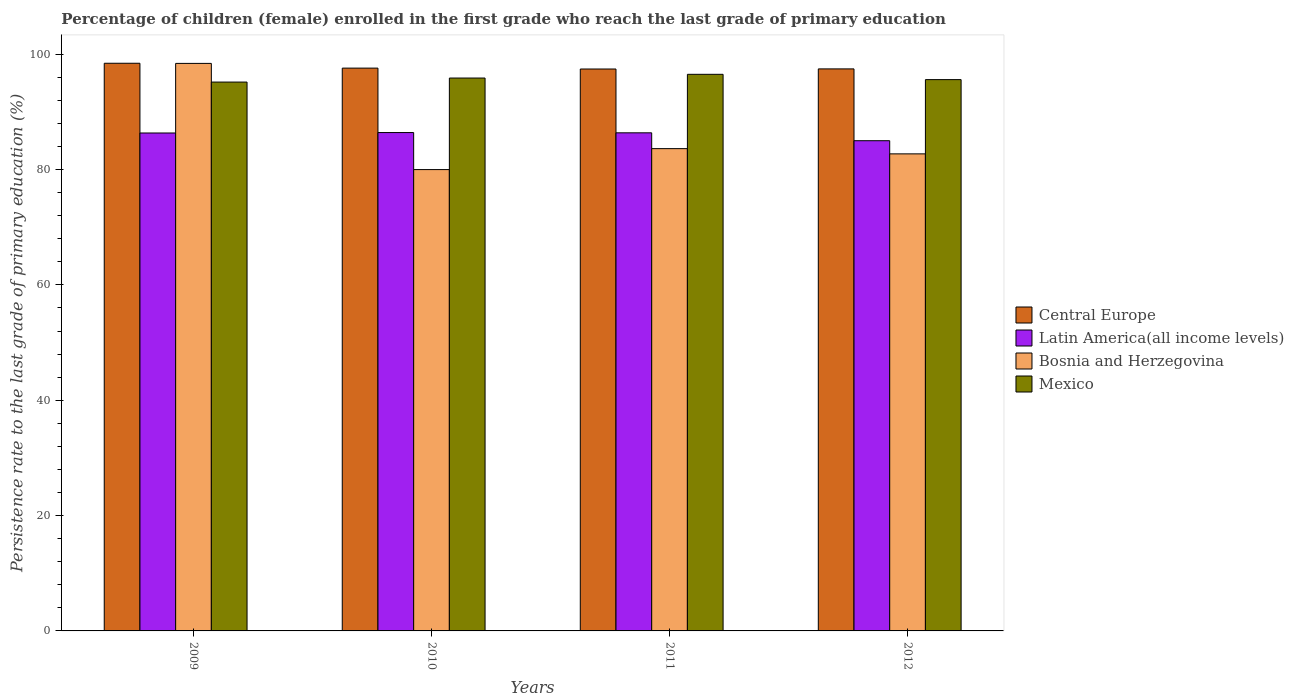How many different coloured bars are there?
Make the answer very short. 4. How many groups of bars are there?
Ensure brevity in your answer.  4. Are the number of bars on each tick of the X-axis equal?
Make the answer very short. Yes. How many bars are there on the 1st tick from the right?
Keep it short and to the point. 4. What is the persistence rate of children in Bosnia and Herzegovina in 2011?
Make the answer very short. 83.63. Across all years, what is the maximum persistence rate of children in Bosnia and Herzegovina?
Your answer should be very brief. 98.41. Across all years, what is the minimum persistence rate of children in Bosnia and Herzegovina?
Ensure brevity in your answer.  80. In which year was the persistence rate of children in Latin America(all income levels) maximum?
Offer a terse response. 2010. In which year was the persistence rate of children in Central Europe minimum?
Make the answer very short. 2011. What is the total persistence rate of children in Mexico in the graph?
Make the answer very short. 383.18. What is the difference between the persistence rate of children in Central Europe in 2009 and that in 2011?
Your answer should be compact. 1. What is the difference between the persistence rate of children in Bosnia and Herzegovina in 2011 and the persistence rate of children in Mexico in 2010?
Your answer should be very brief. -12.24. What is the average persistence rate of children in Bosnia and Herzegovina per year?
Provide a succinct answer. 86.19. In the year 2011, what is the difference between the persistence rate of children in Mexico and persistence rate of children in Central Europe?
Your response must be concise. -0.92. In how many years, is the persistence rate of children in Central Europe greater than 72 %?
Your answer should be compact. 4. What is the ratio of the persistence rate of children in Latin America(all income levels) in 2010 to that in 2012?
Provide a short and direct response. 1.02. Is the persistence rate of children in Bosnia and Herzegovina in 2009 less than that in 2010?
Your response must be concise. No. Is the difference between the persistence rate of children in Mexico in 2010 and 2011 greater than the difference between the persistence rate of children in Central Europe in 2010 and 2011?
Ensure brevity in your answer.  No. What is the difference between the highest and the second highest persistence rate of children in Latin America(all income levels)?
Make the answer very short. 0.05. What is the difference between the highest and the lowest persistence rate of children in Bosnia and Herzegovina?
Ensure brevity in your answer.  18.41. Is it the case that in every year, the sum of the persistence rate of children in Mexico and persistence rate of children in Bosnia and Herzegovina is greater than the sum of persistence rate of children in Central Europe and persistence rate of children in Latin America(all income levels)?
Give a very brief answer. No. What does the 3rd bar from the right in 2012 represents?
Your response must be concise. Latin America(all income levels). Does the graph contain any zero values?
Make the answer very short. No. What is the title of the graph?
Give a very brief answer. Percentage of children (female) enrolled in the first grade who reach the last grade of primary education. Does "New Zealand" appear as one of the legend labels in the graph?
Offer a very short reply. No. What is the label or title of the X-axis?
Your response must be concise. Years. What is the label or title of the Y-axis?
Your response must be concise. Persistence rate to the last grade of primary education (%). What is the Persistence rate to the last grade of primary education (%) in Central Europe in 2009?
Keep it short and to the point. 98.44. What is the Persistence rate to the last grade of primary education (%) in Latin America(all income levels) in 2009?
Offer a terse response. 86.35. What is the Persistence rate to the last grade of primary education (%) of Bosnia and Herzegovina in 2009?
Offer a very short reply. 98.41. What is the Persistence rate to the last grade of primary education (%) in Mexico in 2009?
Provide a succinct answer. 95.18. What is the Persistence rate to the last grade of primary education (%) in Central Europe in 2010?
Offer a very short reply. 97.6. What is the Persistence rate to the last grade of primary education (%) of Latin America(all income levels) in 2010?
Offer a very short reply. 86.42. What is the Persistence rate to the last grade of primary education (%) of Bosnia and Herzegovina in 2010?
Offer a terse response. 80. What is the Persistence rate to the last grade of primary education (%) in Mexico in 2010?
Your answer should be compact. 95.88. What is the Persistence rate to the last grade of primary education (%) in Central Europe in 2011?
Give a very brief answer. 97.44. What is the Persistence rate to the last grade of primary education (%) in Latin America(all income levels) in 2011?
Ensure brevity in your answer.  86.38. What is the Persistence rate to the last grade of primary education (%) in Bosnia and Herzegovina in 2011?
Keep it short and to the point. 83.63. What is the Persistence rate to the last grade of primary education (%) in Mexico in 2011?
Offer a very short reply. 96.52. What is the Persistence rate to the last grade of primary education (%) of Central Europe in 2012?
Make the answer very short. 97.46. What is the Persistence rate to the last grade of primary education (%) of Latin America(all income levels) in 2012?
Make the answer very short. 85.01. What is the Persistence rate to the last grade of primary education (%) in Bosnia and Herzegovina in 2012?
Ensure brevity in your answer.  82.73. What is the Persistence rate to the last grade of primary education (%) of Mexico in 2012?
Your answer should be very brief. 95.6. Across all years, what is the maximum Persistence rate to the last grade of primary education (%) in Central Europe?
Ensure brevity in your answer.  98.44. Across all years, what is the maximum Persistence rate to the last grade of primary education (%) of Latin America(all income levels)?
Your answer should be very brief. 86.42. Across all years, what is the maximum Persistence rate to the last grade of primary education (%) in Bosnia and Herzegovina?
Give a very brief answer. 98.41. Across all years, what is the maximum Persistence rate to the last grade of primary education (%) in Mexico?
Provide a short and direct response. 96.52. Across all years, what is the minimum Persistence rate to the last grade of primary education (%) of Central Europe?
Your answer should be very brief. 97.44. Across all years, what is the minimum Persistence rate to the last grade of primary education (%) in Latin America(all income levels)?
Keep it short and to the point. 85.01. Across all years, what is the minimum Persistence rate to the last grade of primary education (%) in Bosnia and Herzegovina?
Offer a very short reply. 80. Across all years, what is the minimum Persistence rate to the last grade of primary education (%) in Mexico?
Make the answer very short. 95.18. What is the total Persistence rate to the last grade of primary education (%) in Central Europe in the graph?
Keep it short and to the point. 390.94. What is the total Persistence rate to the last grade of primary education (%) of Latin America(all income levels) in the graph?
Your answer should be very brief. 344.15. What is the total Persistence rate to the last grade of primary education (%) in Bosnia and Herzegovina in the graph?
Make the answer very short. 344.78. What is the total Persistence rate to the last grade of primary education (%) of Mexico in the graph?
Provide a succinct answer. 383.18. What is the difference between the Persistence rate to the last grade of primary education (%) of Central Europe in 2009 and that in 2010?
Ensure brevity in your answer.  0.84. What is the difference between the Persistence rate to the last grade of primary education (%) in Latin America(all income levels) in 2009 and that in 2010?
Keep it short and to the point. -0.08. What is the difference between the Persistence rate to the last grade of primary education (%) in Bosnia and Herzegovina in 2009 and that in 2010?
Provide a short and direct response. 18.41. What is the difference between the Persistence rate to the last grade of primary education (%) in Mexico in 2009 and that in 2010?
Ensure brevity in your answer.  -0.7. What is the difference between the Persistence rate to the last grade of primary education (%) in Latin America(all income levels) in 2009 and that in 2011?
Give a very brief answer. -0.03. What is the difference between the Persistence rate to the last grade of primary education (%) in Bosnia and Herzegovina in 2009 and that in 2011?
Make the answer very short. 14.78. What is the difference between the Persistence rate to the last grade of primary education (%) in Mexico in 2009 and that in 2011?
Provide a succinct answer. -1.35. What is the difference between the Persistence rate to the last grade of primary education (%) in Central Europe in 2009 and that in 2012?
Provide a succinct answer. 0.98. What is the difference between the Persistence rate to the last grade of primary education (%) of Latin America(all income levels) in 2009 and that in 2012?
Your response must be concise. 1.34. What is the difference between the Persistence rate to the last grade of primary education (%) of Bosnia and Herzegovina in 2009 and that in 2012?
Give a very brief answer. 15.69. What is the difference between the Persistence rate to the last grade of primary education (%) in Mexico in 2009 and that in 2012?
Your answer should be compact. -0.43. What is the difference between the Persistence rate to the last grade of primary education (%) of Central Europe in 2010 and that in 2011?
Make the answer very short. 0.15. What is the difference between the Persistence rate to the last grade of primary education (%) in Latin America(all income levels) in 2010 and that in 2011?
Ensure brevity in your answer.  0.05. What is the difference between the Persistence rate to the last grade of primary education (%) in Bosnia and Herzegovina in 2010 and that in 2011?
Offer a terse response. -3.63. What is the difference between the Persistence rate to the last grade of primary education (%) in Mexico in 2010 and that in 2011?
Keep it short and to the point. -0.65. What is the difference between the Persistence rate to the last grade of primary education (%) of Central Europe in 2010 and that in 2012?
Ensure brevity in your answer.  0.13. What is the difference between the Persistence rate to the last grade of primary education (%) in Latin America(all income levels) in 2010 and that in 2012?
Your answer should be compact. 1.41. What is the difference between the Persistence rate to the last grade of primary education (%) of Bosnia and Herzegovina in 2010 and that in 2012?
Your response must be concise. -2.73. What is the difference between the Persistence rate to the last grade of primary education (%) of Mexico in 2010 and that in 2012?
Offer a very short reply. 0.27. What is the difference between the Persistence rate to the last grade of primary education (%) in Central Europe in 2011 and that in 2012?
Offer a very short reply. -0.02. What is the difference between the Persistence rate to the last grade of primary education (%) in Latin America(all income levels) in 2011 and that in 2012?
Provide a succinct answer. 1.37. What is the difference between the Persistence rate to the last grade of primary education (%) of Bosnia and Herzegovina in 2011 and that in 2012?
Offer a terse response. 0.91. What is the difference between the Persistence rate to the last grade of primary education (%) of Mexico in 2011 and that in 2012?
Your answer should be compact. 0.92. What is the difference between the Persistence rate to the last grade of primary education (%) in Central Europe in 2009 and the Persistence rate to the last grade of primary education (%) in Latin America(all income levels) in 2010?
Provide a short and direct response. 12.02. What is the difference between the Persistence rate to the last grade of primary education (%) in Central Europe in 2009 and the Persistence rate to the last grade of primary education (%) in Bosnia and Herzegovina in 2010?
Provide a succinct answer. 18.44. What is the difference between the Persistence rate to the last grade of primary education (%) of Central Europe in 2009 and the Persistence rate to the last grade of primary education (%) of Mexico in 2010?
Offer a terse response. 2.56. What is the difference between the Persistence rate to the last grade of primary education (%) in Latin America(all income levels) in 2009 and the Persistence rate to the last grade of primary education (%) in Bosnia and Herzegovina in 2010?
Offer a terse response. 6.35. What is the difference between the Persistence rate to the last grade of primary education (%) in Latin America(all income levels) in 2009 and the Persistence rate to the last grade of primary education (%) in Mexico in 2010?
Offer a terse response. -9.53. What is the difference between the Persistence rate to the last grade of primary education (%) in Bosnia and Herzegovina in 2009 and the Persistence rate to the last grade of primary education (%) in Mexico in 2010?
Make the answer very short. 2.54. What is the difference between the Persistence rate to the last grade of primary education (%) of Central Europe in 2009 and the Persistence rate to the last grade of primary education (%) of Latin America(all income levels) in 2011?
Your answer should be compact. 12.06. What is the difference between the Persistence rate to the last grade of primary education (%) in Central Europe in 2009 and the Persistence rate to the last grade of primary education (%) in Bosnia and Herzegovina in 2011?
Your answer should be very brief. 14.81. What is the difference between the Persistence rate to the last grade of primary education (%) of Central Europe in 2009 and the Persistence rate to the last grade of primary education (%) of Mexico in 2011?
Provide a short and direct response. 1.92. What is the difference between the Persistence rate to the last grade of primary education (%) of Latin America(all income levels) in 2009 and the Persistence rate to the last grade of primary education (%) of Bosnia and Herzegovina in 2011?
Your answer should be compact. 2.71. What is the difference between the Persistence rate to the last grade of primary education (%) of Latin America(all income levels) in 2009 and the Persistence rate to the last grade of primary education (%) of Mexico in 2011?
Make the answer very short. -10.18. What is the difference between the Persistence rate to the last grade of primary education (%) in Bosnia and Herzegovina in 2009 and the Persistence rate to the last grade of primary education (%) in Mexico in 2011?
Provide a succinct answer. 1.89. What is the difference between the Persistence rate to the last grade of primary education (%) in Central Europe in 2009 and the Persistence rate to the last grade of primary education (%) in Latin America(all income levels) in 2012?
Your response must be concise. 13.43. What is the difference between the Persistence rate to the last grade of primary education (%) in Central Europe in 2009 and the Persistence rate to the last grade of primary education (%) in Bosnia and Herzegovina in 2012?
Offer a very short reply. 15.71. What is the difference between the Persistence rate to the last grade of primary education (%) in Central Europe in 2009 and the Persistence rate to the last grade of primary education (%) in Mexico in 2012?
Keep it short and to the point. 2.84. What is the difference between the Persistence rate to the last grade of primary education (%) of Latin America(all income levels) in 2009 and the Persistence rate to the last grade of primary education (%) of Bosnia and Herzegovina in 2012?
Ensure brevity in your answer.  3.62. What is the difference between the Persistence rate to the last grade of primary education (%) of Latin America(all income levels) in 2009 and the Persistence rate to the last grade of primary education (%) of Mexico in 2012?
Give a very brief answer. -9.26. What is the difference between the Persistence rate to the last grade of primary education (%) in Bosnia and Herzegovina in 2009 and the Persistence rate to the last grade of primary education (%) in Mexico in 2012?
Ensure brevity in your answer.  2.81. What is the difference between the Persistence rate to the last grade of primary education (%) of Central Europe in 2010 and the Persistence rate to the last grade of primary education (%) of Latin America(all income levels) in 2011?
Your answer should be compact. 11.22. What is the difference between the Persistence rate to the last grade of primary education (%) of Central Europe in 2010 and the Persistence rate to the last grade of primary education (%) of Bosnia and Herzegovina in 2011?
Offer a very short reply. 13.96. What is the difference between the Persistence rate to the last grade of primary education (%) of Central Europe in 2010 and the Persistence rate to the last grade of primary education (%) of Mexico in 2011?
Ensure brevity in your answer.  1.07. What is the difference between the Persistence rate to the last grade of primary education (%) in Latin America(all income levels) in 2010 and the Persistence rate to the last grade of primary education (%) in Bosnia and Herzegovina in 2011?
Your answer should be compact. 2.79. What is the difference between the Persistence rate to the last grade of primary education (%) of Latin America(all income levels) in 2010 and the Persistence rate to the last grade of primary education (%) of Mexico in 2011?
Your answer should be compact. -10.1. What is the difference between the Persistence rate to the last grade of primary education (%) in Bosnia and Herzegovina in 2010 and the Persistence rate to the last grade of primary education (%) in Mexico in 2011?
Make the answer very short. -16.52. What is the difference between the Persistence rate to the last grade of primary education (%) in Central Europe in 2010 and the Persistence rate to the last grade of primary education (%) in Latin America(all income levels) in 2012?
Offer a terse response. 12.59. What is the difference between the Persistence rate to the last grade of primary education (%) in Central Europe in 2010 and the Persistence rate to the last grade of primary education (%) in Bosnia and Herzegovina in 2012?
Offer a very short reply. 14.87. What is the difference between the Persistence rate to the last grade of primary education (%) of Central Europe in 2010 and the Persistence rate to the last grade of primary education (%) of Mexico in 2012?
Your answer should be very brief. 1.99. What is the difference between the Persistence rate to the last grade of primary education (%) of Latin America(all income levels) in 2010 and the Persistence rate to the last grade of primary education (%) of Bosnia and Herzegovina in 2012?
Provide a succinct answer. 3.7. What is the difference between the Persistence rate to the last grade of primary education (%) of Latin America(all income levels) in 2010 and the Persistence rate to the last grade of primary education (%) of Mexico in 2012?
Provide a short and direct response. -9.18. What is the difference between the Persistence rate to the last grade of primary education (%) in Bosnia and Herzegovina in 2010 and the Persistence rate to the last grade of primary education (%) in Mexico in 2012?
Provide a short and direct response. -15.6. What is the difference between the Persistence rate to the last grade of primary education (%) in Central Europe in 2011 and the Persistence rate to the last grade of primary education (%) in Latin America(all income levels) in 2012?
Provide a succinct answer. 12.43. What is the difference between the Persistence rate to the last grade of primary education (%) in Central Europe in 2011 and the Persistence rate to the last grade of primary education (%) in Bosnia and Herzegovina in 2012?
Give a very brief answer. 14.72. What is the difference between the Persistence rate to the last grade of primary education (%) in Central Europe in 2011 and the Persistence rate to the last grade of primary education (%) in Mexico in 2012?
Provide a succinct answer. 1.84. What is the difference between the Persistence rate to the last grade of primary education (%) in Latin America(all income levels) in 2011 and the Persistence rate to the last grade of primary education (%) in Bosnia and Herzegovina in 2012?
Provide a short and direct response. 3.65. What is the difference between the Persistence rate to the last grade of primary education (%) of Latin America(all income levels) in 2011 and the Persistence rate to the last grade of primary education (%) of Mexico in 2012?
Keep it short and to the point. -9.23. What is the difference between the Persistence rate to the last grade of primary education (%) in Bosnia and Herzegovina in 2011 and the Persistence rate to the last grade of primary education (%) in Mexico in 2012?
Provide a succinct answer. -11.97. What is the average Persistence rate to the last grade of primary education (%) of Central Europe per year?
Your response must be concise. 97.74. What is the average Persistence rate to the last grade of primary education (%) in Latin America(all income levels) per year?
Offer a very short reply. 86.04. What is the average Persistence rate to the last grade of primary education (%) of Bosnia and Herzegovina per year?
Offer a very short reply. 86.19. What is the average Persistence rate to the last grade of primary education (%) in Mexico per year?
Your answer should be compact. 95.79. In the year 2009, what is the difference between the Persistence rate to the last grade of primary education (%) of Central Europe and Persistence rate to the last grade of primary education (%) of Latin America(all income levels)?
Your response must be concise. 12.09. In the year 2009, what is the difference between the Persistence rate to the last grade of primary education (%) in Central Europe and Persistence rate to the last grade of primary education (%) in Bosnia and Herzegovina?
Your response must be concise. 0.02. In the year 2009, what is the difference between the Persistence rate to the last grade of primary education (%) of Central Europe and Persistence rate to the last grade of primary education (%) of Mexico?
Give a very brief answer. 3.26. In the year 2009, what is the difference between the Persistence rate to the last grade of primary education (%) in Latin America(all income levels) and Persistence rate to the last grade of primary education (%) in Bosnia and Herzegovina?
Provide a succinct answer. -12.07. In the year 2009, what is the difference between the Persistence rate to the last grade of primary education (%) of Latin America(all income levels) and Persistence rate to the last grade of primary education (%) of Mexico?
Offer a terse response. -8.83. In the year 2009, what is the difference between the Persistence rate to the last grade of primary education (%) in Bosnia and Herzegovina and Persistence rate to the last grade of primary education (%) in Mexico?
Ensure brevity in your answer.  3.24. In the year 2010, what is the difference between the Persistence rate to the last grade of primary education (%) of Central Europe and Persistence rate to the last grade of primary education (%) of Latin America(all income levels)?
Keep it short and to the point. 11.17. In the year 2010, what is the difference between the Persistence rate to the last grade of primary education (%) in Central Europe and Persistence rate to the last grade of primary education (%) in Bosnia and Herzegovina?
Offer a terse response. 17.6. In the year 2010, what is the difference between the Persistence rate to the last grade of primary education (%) of Central Europe and Persistence rate to the last grade of primary education (%) of Mexico?
Your response must be concise. 1.72. In the year 2010, what is the difference between the Persistence rate to the last grade of primary education (%) of Latin America(all income levels) and Persistence rate to the last grade of primary education (%) of Bosnia and Herzegovina?
Offer a very short reply. 6.42. In the year 2010, what is the difference between the Persistence rate to the last grade of primary education (%) in Latin America(all income levels) and Persistence rate to the last grade of primary education (%) in Mexico?
Provide a short and direct response. -9.45. In the year 2010, what is the difference between the Persistence rate to the last grade of primary education (%) of Bosnia and Herzegovina and Persistence rate to the last grade of primary education (%) of Mexico?
Offer a very short reply. -15.88. In the year 2011, what is the difference between the Persistence rate to the last grade of primary education (%) in Central Europe and Persistence rate to the last grade of primary education (%) in Latin America(all income levels)?
Provide a succinct answer. 11.07. In the year 2011, what is the difference between the Persistence rate to the last grade of primary education (%) of Central Europe and Persistence rate to the last grade of primary education (%) of Bosnia and Herzegovina?
Your answer should be very brief. 13.81. In the year 2011, what is the difference between the Persistence rate to the last grade of primary education (%) of Central Europe and Persistence rate to the last grade of primary education (%) of Mexico?
Provide a short and direct response. 0.92. In the year 2011, what is the difference between the Persistence rate to the last grade of primary education (%) in Latin America(all income levels) and Persistence rate to the last grade of primary education (%) in Bosnia and Herzegovina?
Offer a terse response. 2.74. In the year 2011, what is the difference between the Persistence rate to the last grade of primary education (%) of Latin America(all income levels) and Persistence rate to the last grade of primary education (%) of Mexico?
Ensure brevity in your answer.  -10.15. In the year 2011, what is the difference between the Persistence rate to the last grade of primary education (%) of Bosnia and Herzegovina and Persistence rate to the last grade of primary education (%) of Mexico?
Offer a terse response. -12.89. In the year 2012, what is the difference between the Persistence rate to the last grade of primary education (%) of Central Europe and Persistence rate to the last grade of primary education (%) of Latin America(all income levels)?
Ensure brevity in your answer.  12.46. In the year 2012, what is the difference between the Persistence rate to the last grade of primary education (%) of Central Europe and Persistence rate to the last grade of primary education (%) of Bosnia and Herzegovina?
Ensure brevity in your answer.  14.74. In the year 2012, what is the difference between the Persistence rate to the last grade of primary education (%) in Central Europe and Persistence rate to the last grade of primary education (%) in Mexico?
Ensure brevity in your answer.  1.86. In the year 2012, what is the difference between the Persistence rate to the last grade of primary education (%) of Latin America(all income levels) and Persistence rate to the last grade of primary education (%) of Bosnia and Herzegovina?
Your answer should be very brief. 2.28. In the year 2012, what is the difference between the Persistence rate to the last grade of primary education (%) of Latin America(all income levels) and Persistence rate to the last grade of primary education (%) of Mexico?
Ensure brevity in your answer.  -10.6. In the year 2012, what is the difference between the Persistence rate to the last grade of primary education (%) in Bosnia and Herzegovina and Persistence rate to the last grade of primary education (%) in Mexico?
Your answer should be very brief. -12.88. What is the ratio of the Persistence rate to the last grade of primary education (%) of Central Europe in 2009 to that in 2010?
Your answer should be compact. 1.01. What is the ratio of the Persistence rate to the last grade of primary education (%) of Latin America(all income levels) in 2009 to that in 2010?
Your response must be concise. 1. What is the ratio of the Persistence rate to the last grade of primary education (%) in Bosnia and Herzegovina in 2009 to that in 2010?
Make the answer very short. 1.23. What is the ratio of the Persistence rate to the last grade of primary education (%) of Mexico in 2009 to that in 2010?
Provide a succinct answer. 0.99. What is the ratio of the Persistence rate to the last grade of primary education (%) of Central Europe in 2009 to that in 2011?
Make the answer very short. 1.01. What is the ratio of the Persistence rate to the last grade of primary education (%) in Bosnia and Herzegovina in 2009 to that in 2011?
Your answer should be compact. 1.18. What is the ratio of the Persistence rate to the last grade of primary education (%) of Mexico in 2009 to that in 2011?
Offer a very short reply. 0.99. What is the ratio of the Persistence rate to the last grade of primary education (%) in Latin America(all income levels) in 2009 to that in 2012?
Offer a terse response. 1.02. What is the ratio of the Persistence rate to the last grade of primary education (%) of Bosnia and Herzegovina in 2009 to that in 2012?
Offer a very short reply. 1.19. What is the ratio of the Persistence rate to the last grade of primary education (%) of Central Europe in 2010 to that in 2011?
Offer a terse response. 1. What is the ratio of the Persistence rate to the last grade of primary education (%) in Bosnia and Herzegovina in 2010 to that in 2011?
Your response must be concise. 0.96. What is the ratio of the Persistence rate to the last grade of primary education (%) in Mexico in 2010 to that in 2011?
Make the answer very short. 0.99. What is the ratio of the Persistence rate to the last grade of primary education (%) in Latin America(all income levels) in 2010 to that in 2012?
Provide a short and direct response. 1.02. What is the ratio of the Persistence rate to the last grade of primary education (%) of Bosnia and Herzegovina in 2010 to that in 2012?
Give a very brief answer. 0.97. What is the ratio of the Persistence rate to the last grade of primary education (%) in Latin America(all income levels) in 2011 to that in 2012?
Keep it short and to the point. 1.02. What is the ratio of the Persistence rate to the last grade of primary education (%) of Mexico in 2011 to that in 2012?
Offer a very short reply. 1.01. What is the difference between the highest and the second highest Persistence rate to the last grade of primary education (%) in Central Europe?
Offer a terse response. 0.84. What is the difference between the highest and the second highest Persistence rate to the last grade of primary education (%) of Latin America(all income levels)?
Give a very brief answer. 0.05. What is the difference between the highest and the second highest Persistence rate to the last grade of primary education (%) in Bosnia and Herzegovina?
Make the answer very short. 14.78. What is the difference between the highest and the second highest Persistence rate to the last grade of primary education (%) of Mexico?
Offer a terse response. 0.65. What is the difference between the highest and the lowest Persistence rate to the last grade of primary education (%) of Central Europe?
Ensure brevity in your answer.  1. What is the difference between the highest and the lowest Persistence rate to the last grade of primary education (%) of Latin America(all income levels)?
Your answer should be compact. 1.41. What is the difference between the highest and the lowest Persistence rate to the last grade of primary education (%) of Bosnia and Herzegovina?
Make the answer very short. 18.41. What is the difference between the highest and the lowest Persistence rate to the last grade of primary education (%) in Mexico?
Ensure brevity in your answer.  1.35. 